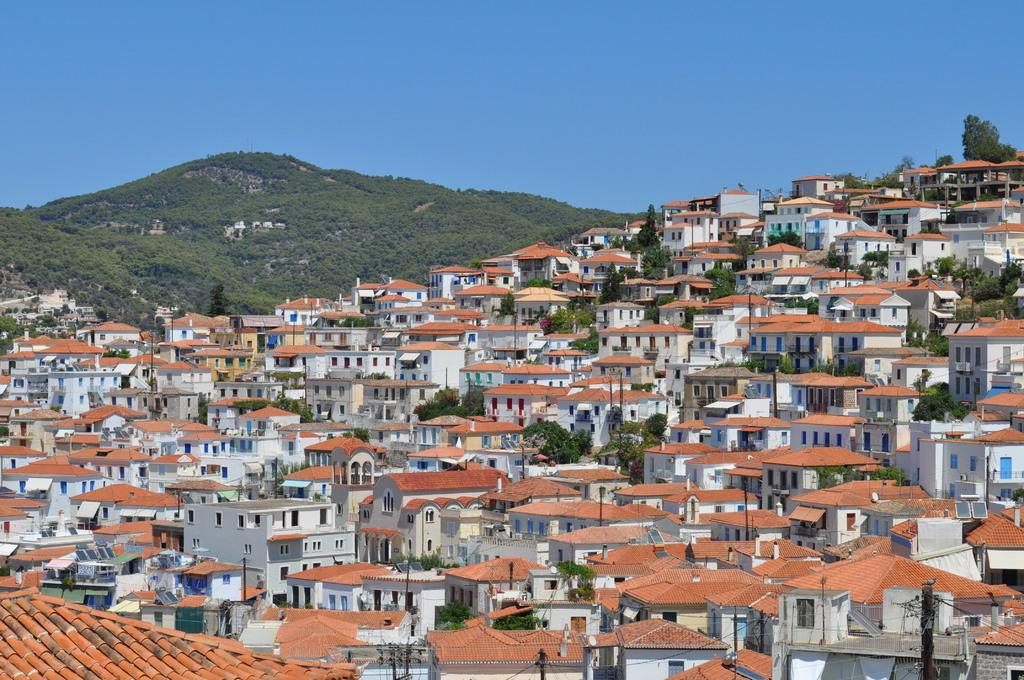What type of structures can be seen in the image? There are buildings in the image. What natural feature is present in the image? There is a mountain in the image. What is the condition of the sky in the image? The sky is clear in the image. Can you tell me how many rivers are flowing through the mountain in the image? There are no rivers visible in the image; it features buildings and a mountain with a clear sky. What type of quicksand can be seen near the buildings in the image? There is no quicksand present in the image; it only features buildings, a mountain, and a clear sky. 